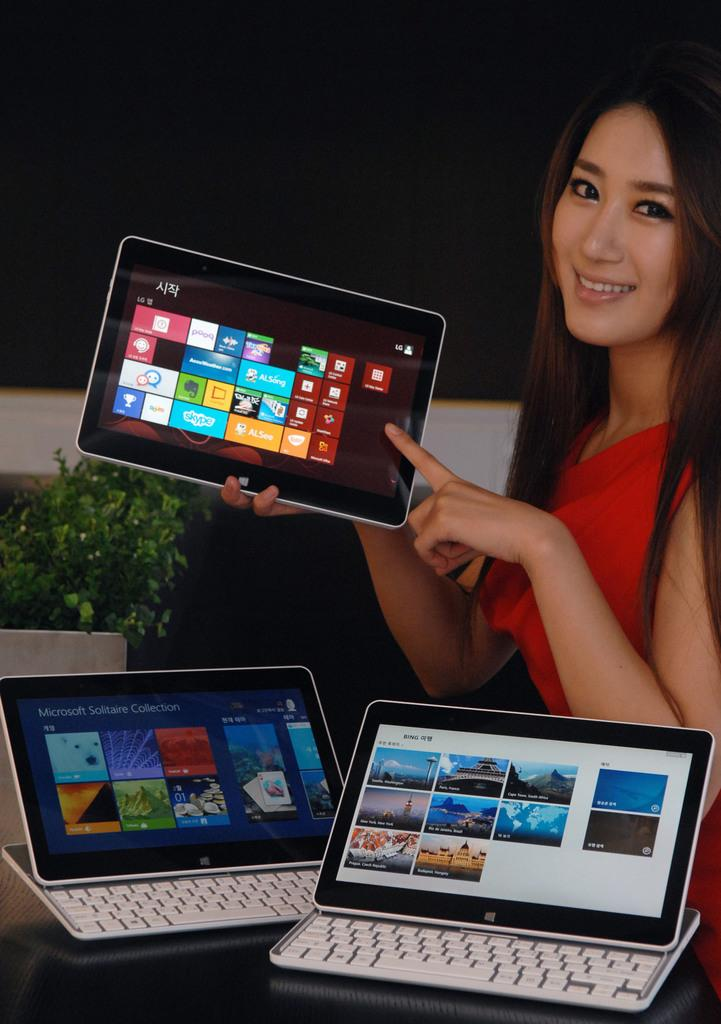Who is the main subject in the image? There is a lady in the image. What is the lady holding in the image? The lady is holding a laptop. Are there any other laptops visible in the image? Yes, there are two other laptops on the table. What type of curtain is hanging near the lady in the image? There is no curtain present in the image. 